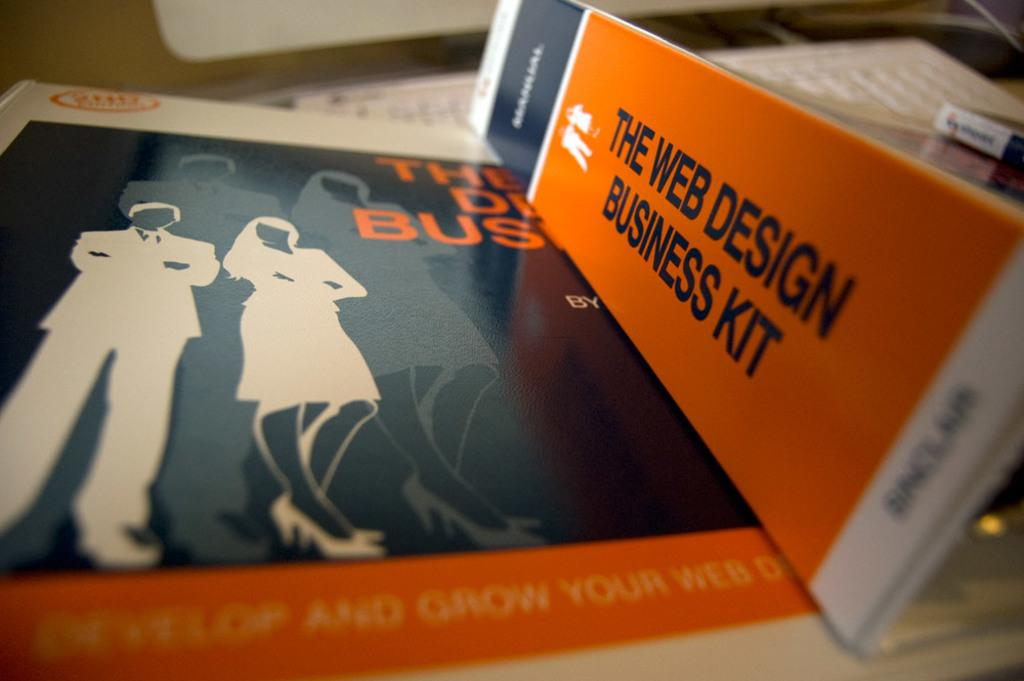<image>
Give a short and clear explanation of the subsequent image. The spine of a binder says The Web Design Business Kit. 